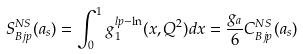<formula> <loc_0><loc_0><loc_500><loc_500>S _ { B j p } ^ { N S } ( a _ { s } ) = \int _ { 0 } ^ { 1 } g _ { 1 } ^ { l p - \ln } ( x , Q ^ { 2 } ) d x = \frac { g _ { a } } { 6 } C _ { B j p } ^ { N S } ( a _ { s } )</formula> 